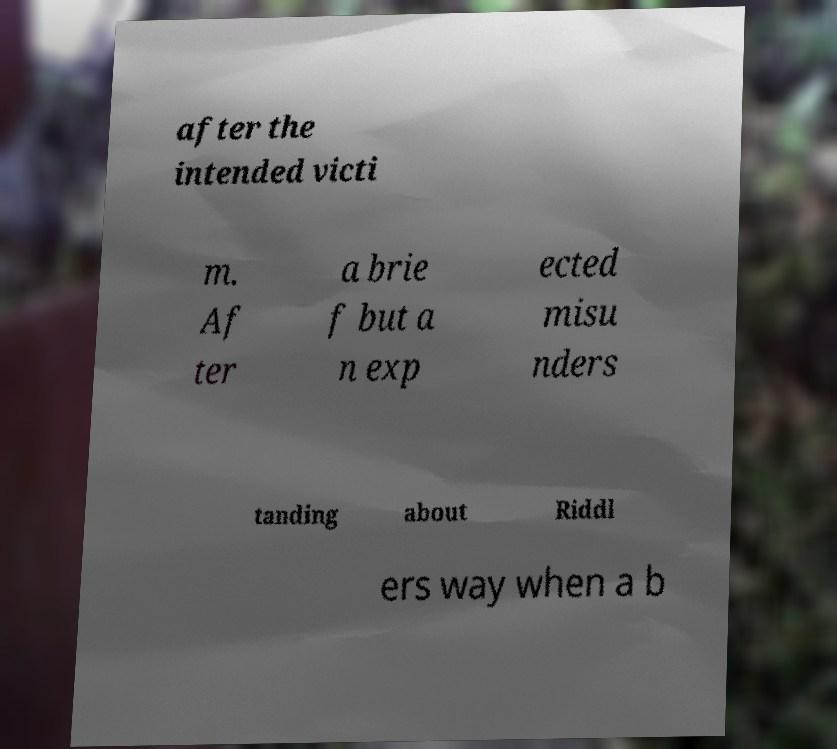Please identify and transcribe the text found in this image. after the intended victi m. Af ter a brie f but a n exp ected misu nders tanding about Riddl ers way when a b 